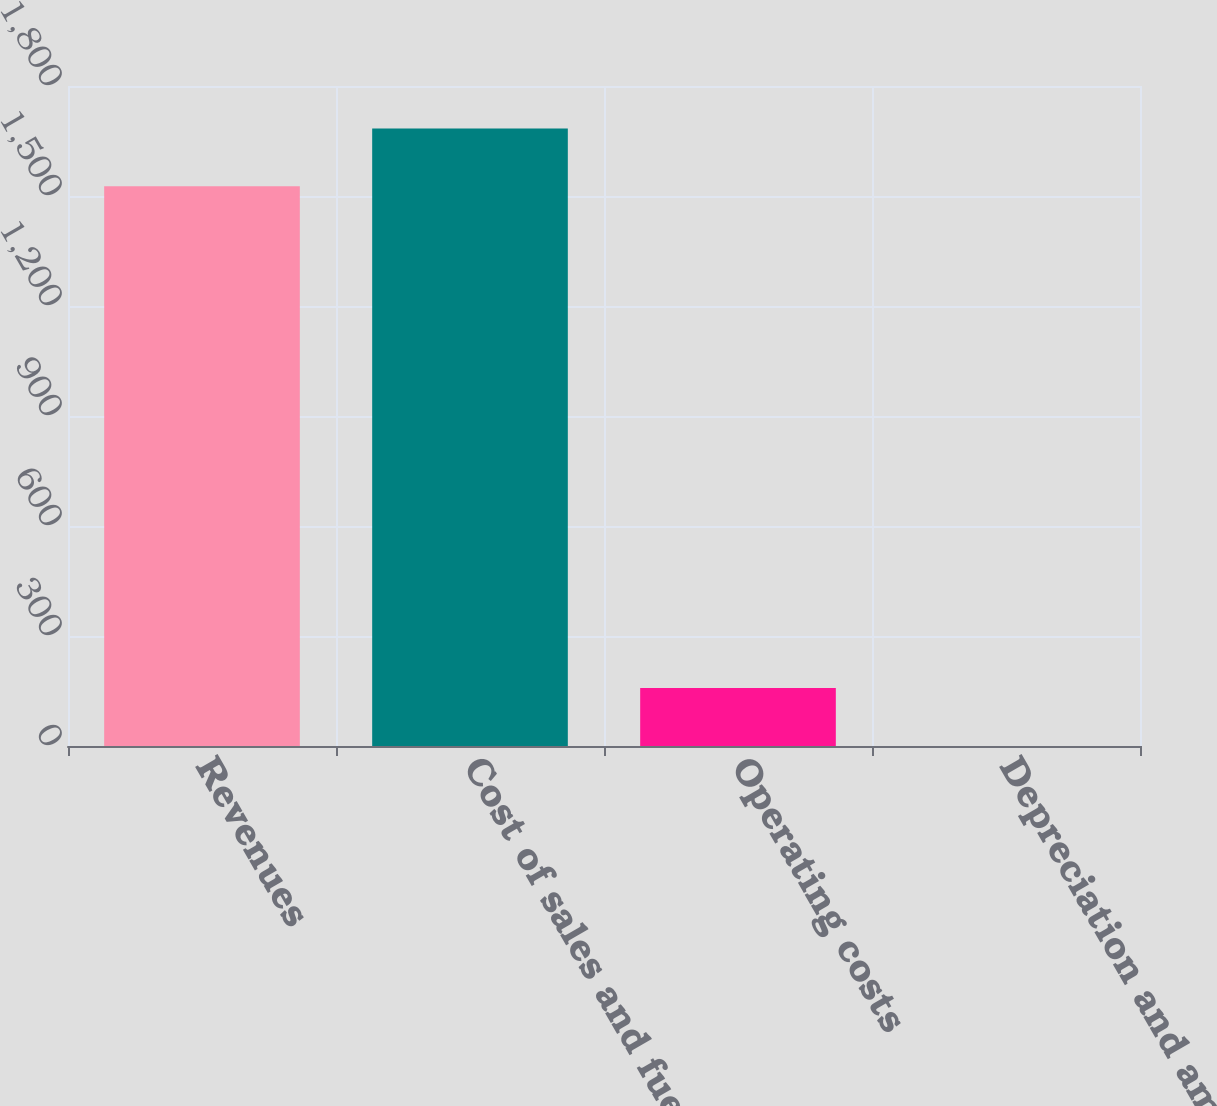Convert chart to OTSL. <chart><loc_0><loc_0><loc_500><loc_500><bar_chart><fcel>Revenues<fcel>Cost of sales and fuel<fcel>Operating costs<fcel>Depreciation and amortization<nl><fcel>1526.6<fcel>1684.16<fcel>157.86<fcel>0.3<nl></chart> 